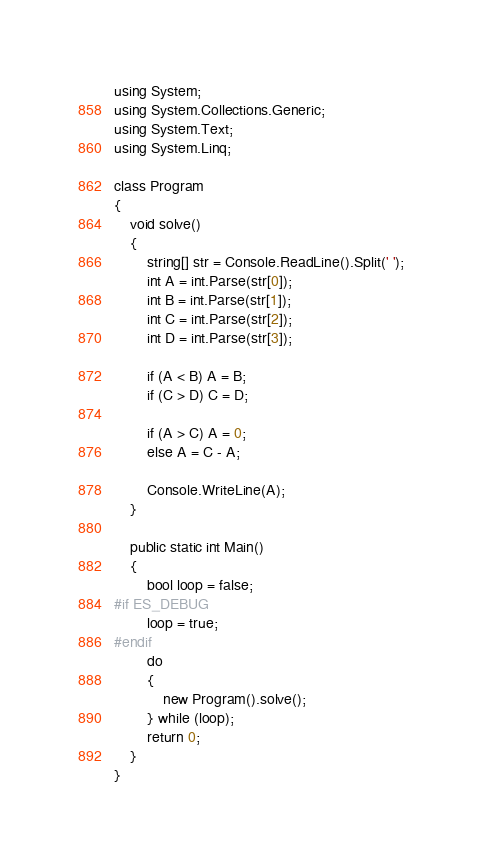<code> <loc_0><loc_0><loc_500><loc_500><_C#_>using System;
using System.Collections.Generic;
using System.Text;
using System.Linq;

class Program
{
    void solve()
    {
        string[] str = Console.ReadLine().Split(' ');
        int A = int.Parse(str[0]);
        int B = int.Parse(str[1]);
        int C = int.Parse(str[2]);
        int D = int.Parse(str[3]);

        if (A < B) A = B;
        if (C > D) C = D;

        if (A > C) A = 0;
        else A = C - A;

        Console.WriteLine(A);
    }

    public static int Main()
    {
        bool loop = false;
#if ES_DEBUG
        loop = true;
#endif
        do
        {
            new Program().solve();
        } while (loop);
        return 0;
    }
}
</code> 